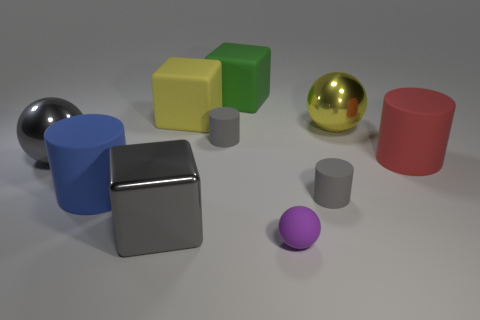What shape is the metal object that is the same color as the shiny cube?
Your answer should be very brief. Sphere. There is a large gray object in front of the red cylinder; what is it made of?
Give a very brief answer. Metal. Are there fewer things behind the large red matte cylinder than yellow shiny spheres?
Make the answer very short. No. The matte thing left of the large rubber cube that is on the left side of the large green object is what shape?
Offer a terse response. Cylinder. What color is the metal cube?
Keep it short and to the point. Gray. What number of other objects are the same size as the green matte thing?
Keep it short and to the point. 6. There is a object that is both to the right of the purple rubber sphere and in front of the large blue object; what is its material?
Provide a short and direct response. Rubber. There is a cube that is on the right side of the yellow cube; is it the same size as the tiny sphere?
Your answer should be very brief. No. Is the rubber ball the same color as the shiny block?
Ensure brevity in your answer.  No. What number of gray things are in front of the big red object and on the left side of the big yellow rubber block?
Ensure brevity in your answer.  1. 